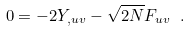Convert formula to latex. <formula><loc_0><loc_0><loc_500><loc_500>0 = - 2 Y _ { , u v } - \sqrt { 2 N } F _ { u v } \ .</formula> 